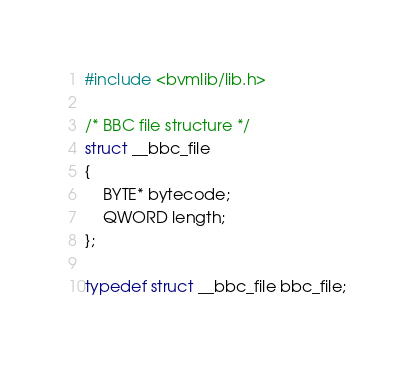<code> <loc_0><loc_0><loc_500><loc_500><_C_>#include <bvmlib/lib.h>

/* BBC file structure */
struct __bbc_file
{
    BYTE* bytecode;
    QWORD length;
};

typedef struct __bbc_file bbc_file;
</code> 